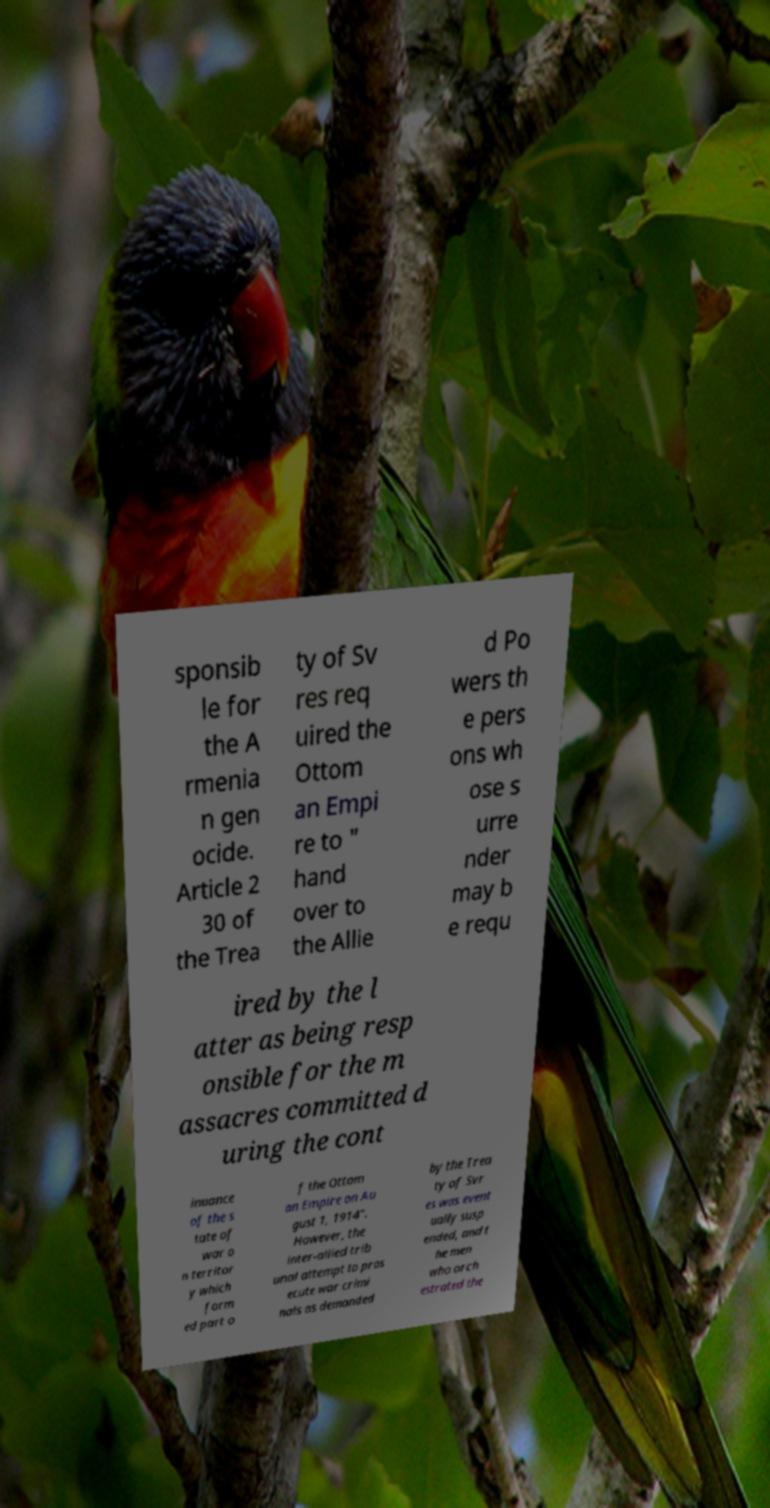What messages or text are displayed in this image? I need them in a readable, typed format. sponsib le for the A rmenia n gen ocide. Article 2 30 of the Trea ty of Sv res req uired the Ottom an Empi re to " hand over to the Allie d Po wers th e pers ons wh ose s urre nder may b e requ ired by the l atter as being resp onsible for the m assacres committed d uring the cont inuance of the s tate of war o n territor y which form ed part o f the Ottom an Empire on Au gust 1, 1914". However, the inter-allied trib unal attempt to pros ecute war crimi nals as demanded by the Trea ty of Svr es was event ually susp ended, and t he men who orch estrated the 